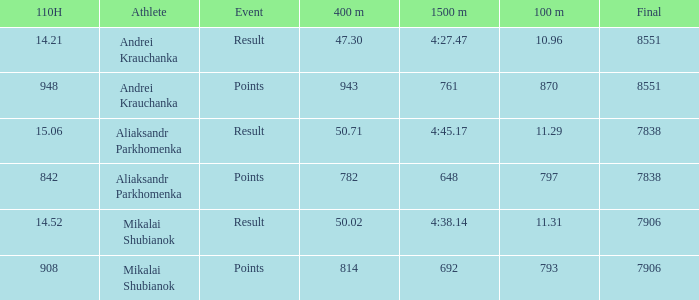What was the 110H that the 1500m was 692 and the final was more than 7906? 0.0. 